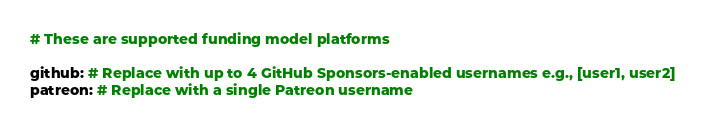<code> <loc_0><loc_0><loc_500><loc_500><_YAML_># These are supported funding model platforms

github: # Replace with up to 4 GitHub Sponsors-enabled usernames e.g., [user1, user2]
patreon: # Replace with a single Patreon username</code> 